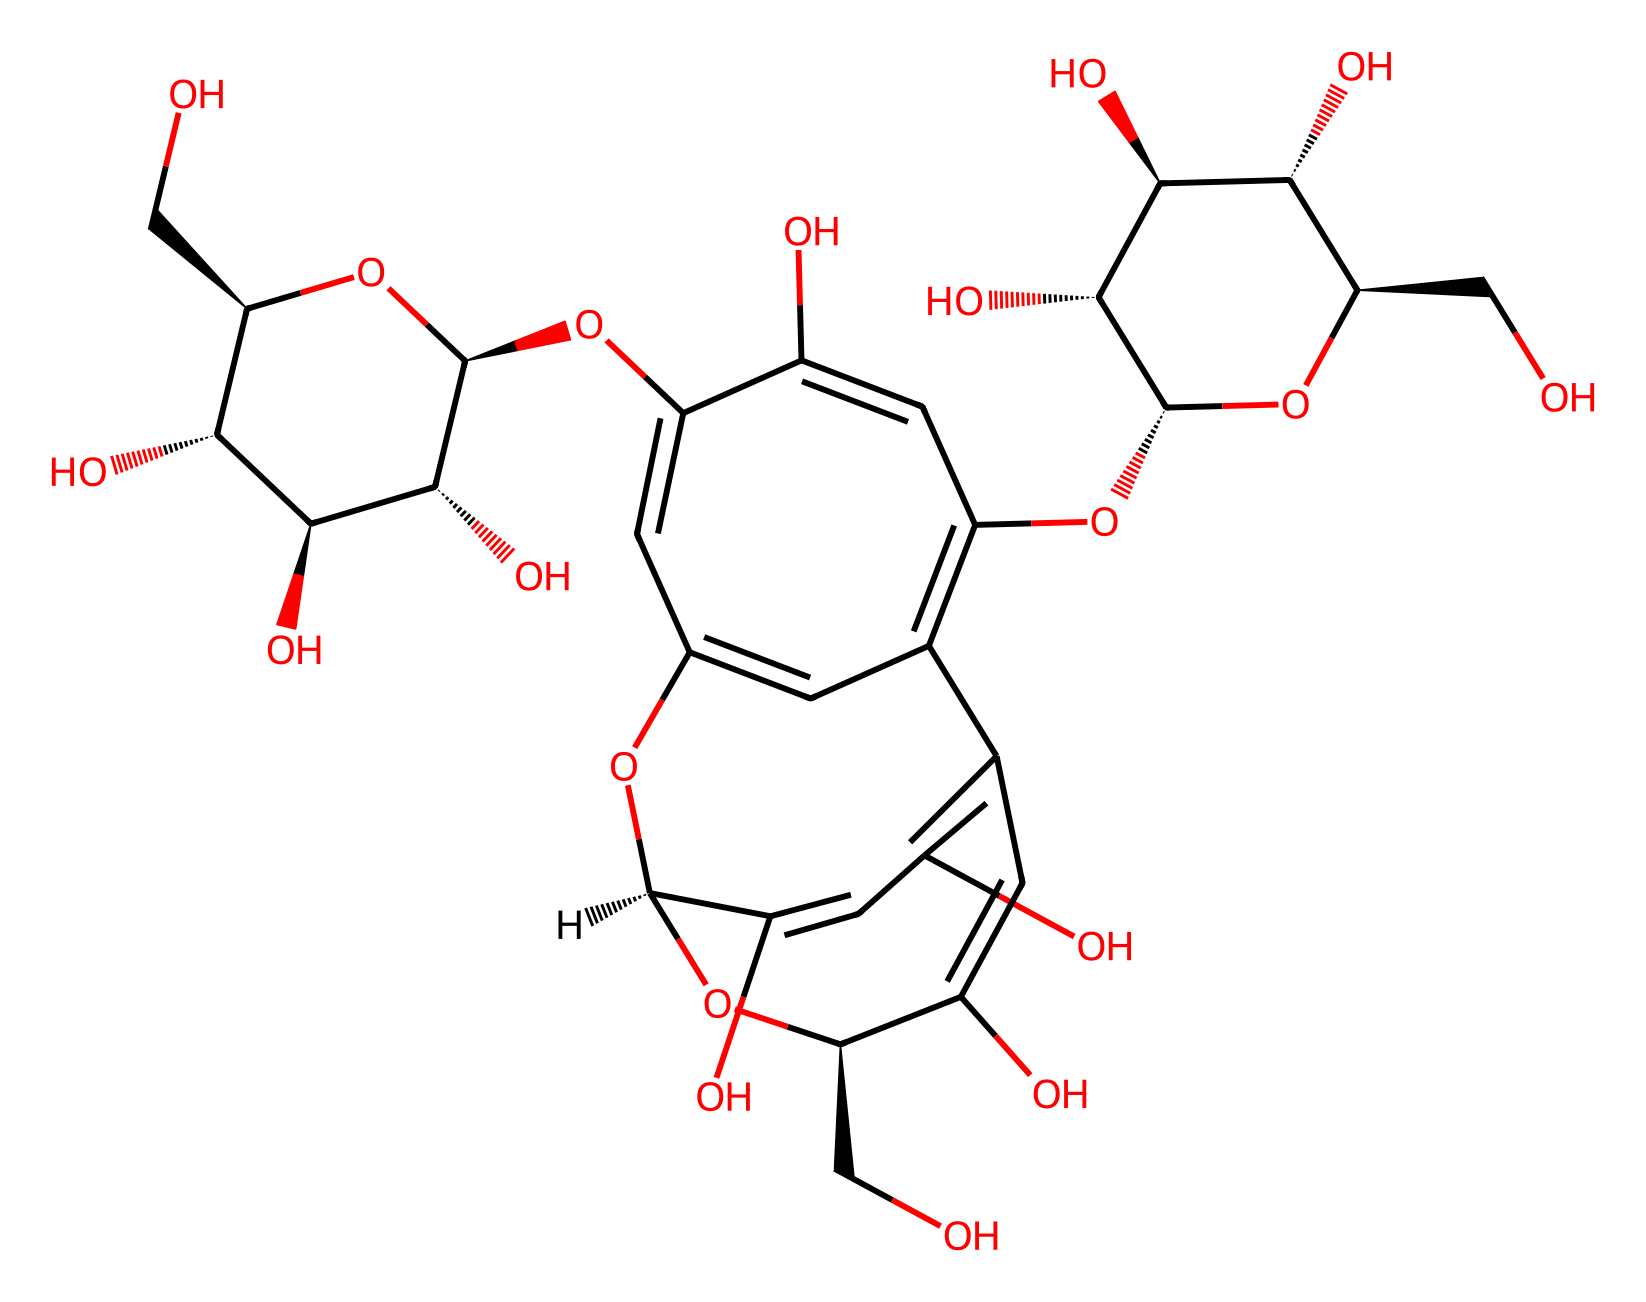How many carbon atoms are in the chemical structure? To find the number of carbon atoms in the SMILES representation, we identify each 'C' character. By counting all occurrences of 'C', we find there are 21 carbon atoms in the structure.
Answer: 21 What functional groups are present in this molecule? By analyzing the SMILES representation, we look for typical functional group indicators, such as 'O' for alcohols and ethers. The structure includes numerous hydroxyl (-OH) groups and ether linkages, indicating the presence of polyols or flavonoid-like compounds.
Answer: hydroxyl and ether Is this molecule more hydrophilic or hydrophobic? The presence of multiple hydroxyl groups in the chemical structure suggests a strong ability to form hydrogen bonds with water, indicating the molecule is hydrophilic.
Answer: hydrophilic What type of chemical is represented by this structure? Since the analyzation involves the presence of acid anhydride characteristics such as the cyclic structure and carboxylic derivatives, this confirms it as a type of acid anhydride related to pigment compounds like anthocyanins or flavonoids found in red rose petals.
Answer: acid anhydride How many rings are present in the structure? By carefully examining the SMILES representation, we identify rings formed within the structure. This molecule contains three rings, as indicated by the numbers connecting through 'c' characters which represent aromatic carbon atoms.
Answer: 3 What is the primary color associated with the pigments in this structure? Research into the typical colors attributed to similar structures, particularly those containing anthocyanin-like features, reveals that they primarily absorb wavelengths corresponding to red, thus appearing red themselves.
Answer: red 